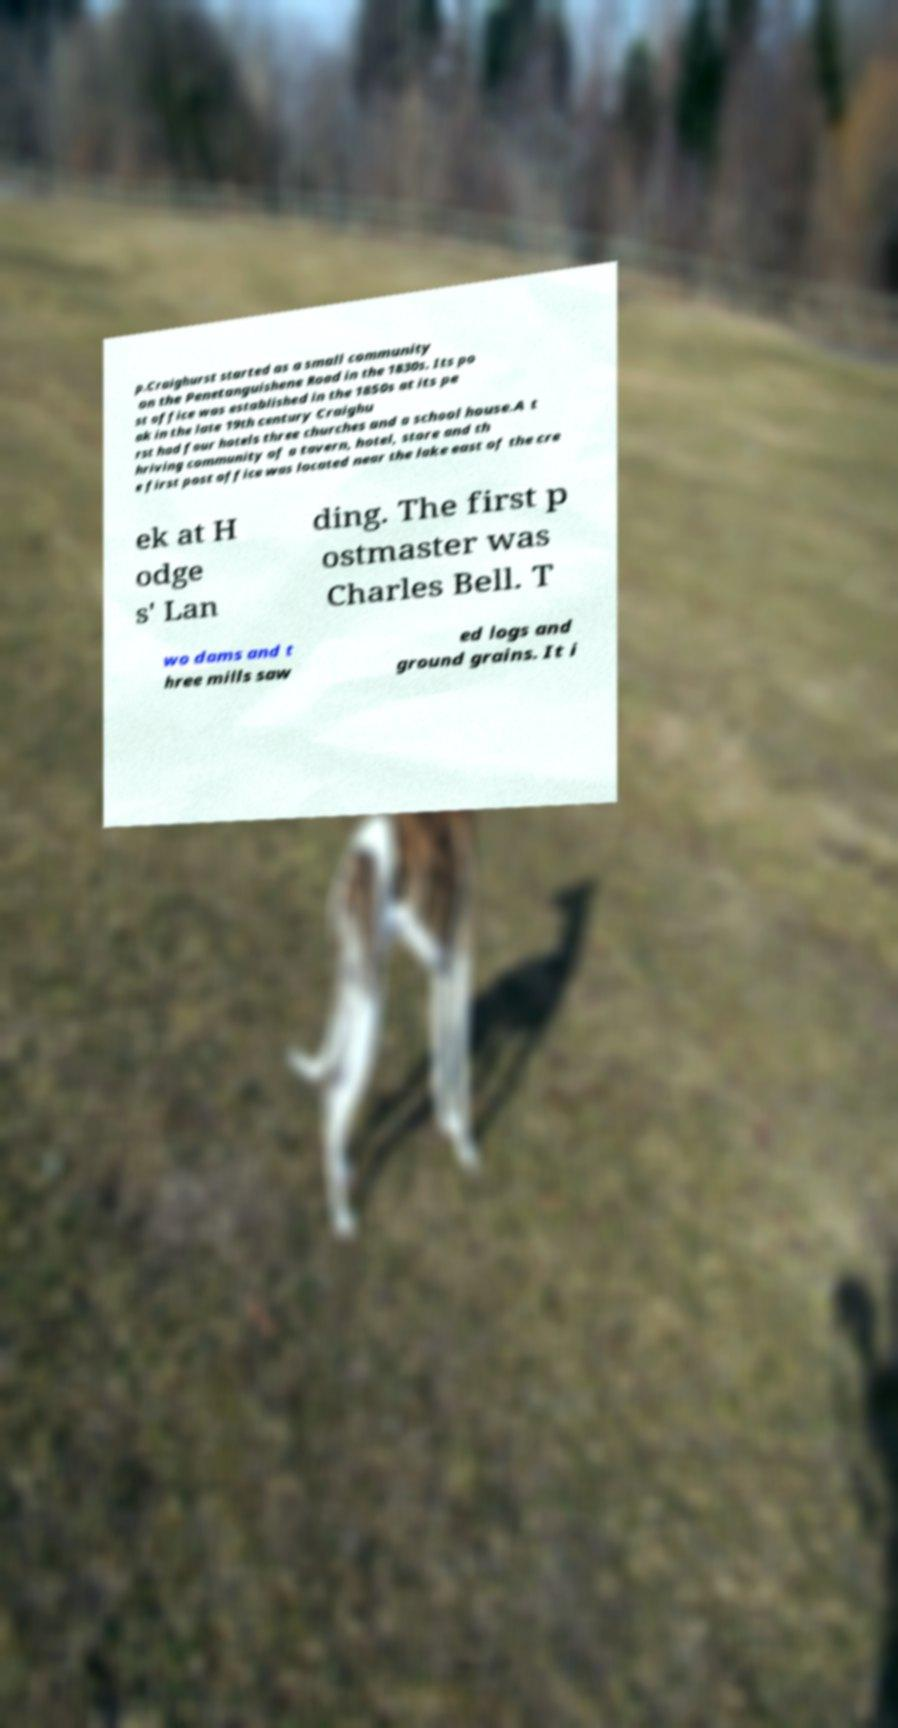Could you extract and type out the text from this image? p.Craighurst started as a small community on the Penetanguishene Road in the 1830s. Its po st office was established in the 1850s at its pe ak in the late 19th century Craighu rst had four hotels three churches and a school house.A t hriving community of a tavern, hotel, store and th e first post office was located near the lake east of the cre ek at H odge s' Lan ding. The first p ostmaster was Charles Bell. T wo dams and t hree mills saw ed logs and ground grains. It i 